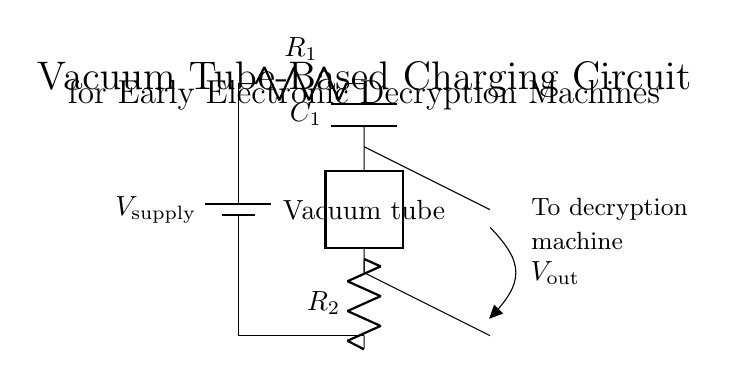What is the type of charging circuit shown? The circuit is a vacuum tube-based charging circuit, identifiable by the use of a vacuum tube component labeled as "Vacuum tube" in the diagram.
Answer: Vacuum tube-based What component is used to store charge in this circuit? The circuit includes a capacitor labeled "C_1," which functions to store electrical charge.
Answer: Capacitor How many resistors are present in the circuit? There are two resistors in the circuit, as indicated by the labels for R_1 and R_2 in the diagram.
Answer: Two What is the output voltage denoted as in this circuit? The output voltage is denoted as "V_out," indicating the potential difference available for the output connections in decryption.
Answer: V_out Which component controls current flow in this circuit? The vacuum tube component acts as the controlling device for current flow, allowing or blocking current based on its operation.
Answer: Vacuum tube What is the purpose of the capacitor in this circuit? The purpose of the capacitor "C_1" is to smooth the output voltage by storing and releasing electrical energy as needed, which is essential for stable operation in decryption machines.
Answer: Smooth output voltage What happens to the voltage at the output if R_1 increases? If R_1 increases, the total circuit resistance increases; therefore, the current through the circuit will decrease, which in turn reduces the voltage output (V_out).
Answer: Reduces output voltage 